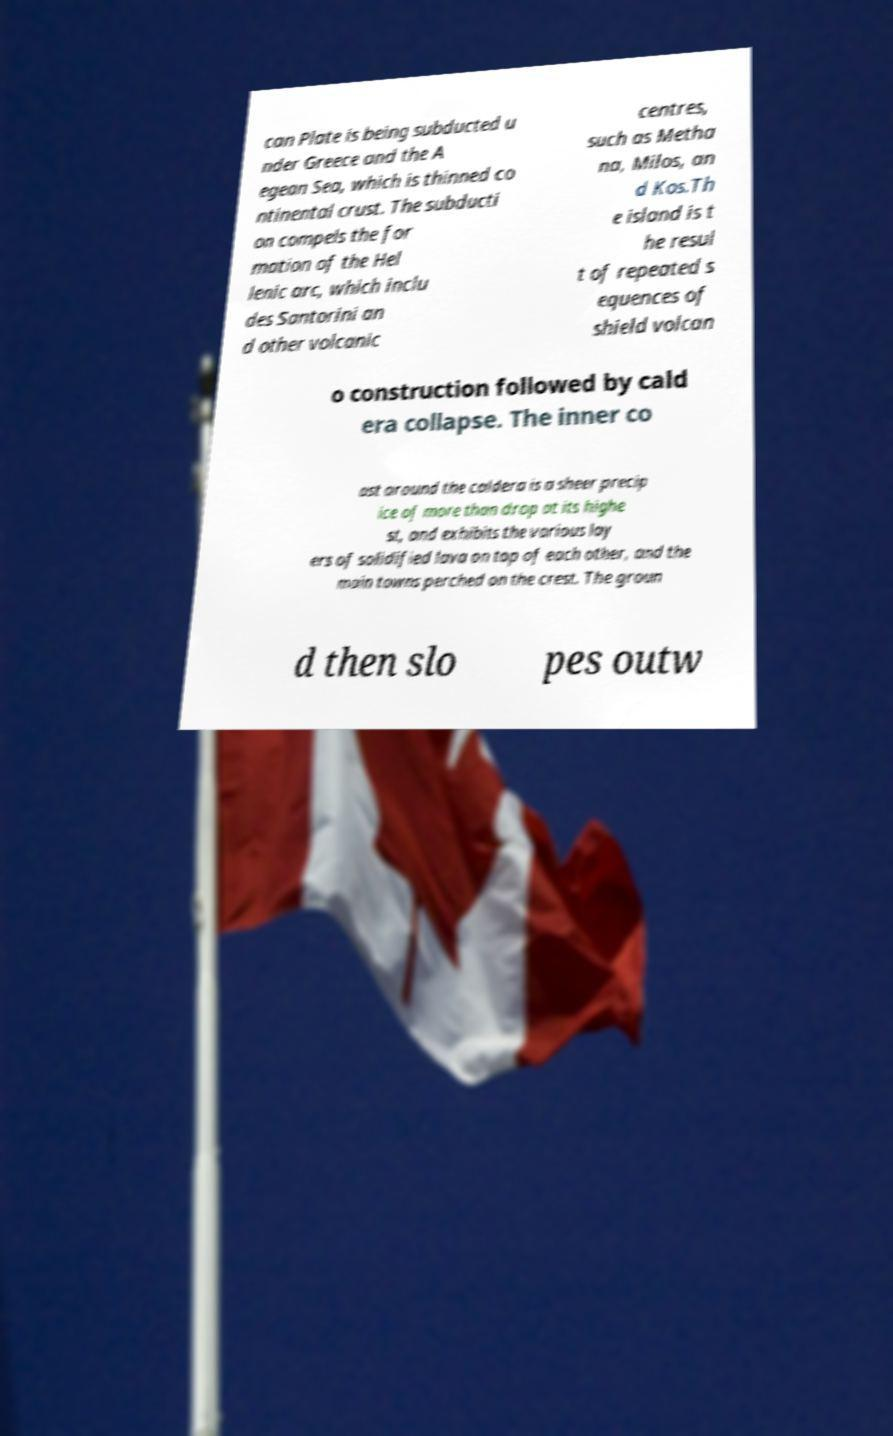I need the written content from this picture converted into text. Can you do that? can Plate is being subducted u nder Greece and the A egean Sea, which is thinned co ntinental crust. The subducti on compels the for mation of the Hel lenic arc, which inclu des Santorini an d other volcanic centres, such as Metha na, Milos, an d Kos.Th e island is t he resul t of repeated s equences of shield volcan o construction followed by cald era collapse. The inner co ast around the caldera is a sheer precip ice of more than drop at its highe st, and exhibits the various lay ers of solidified lava on top of each other, and the main towns perched on the crest. The groun d then slo pes outw 